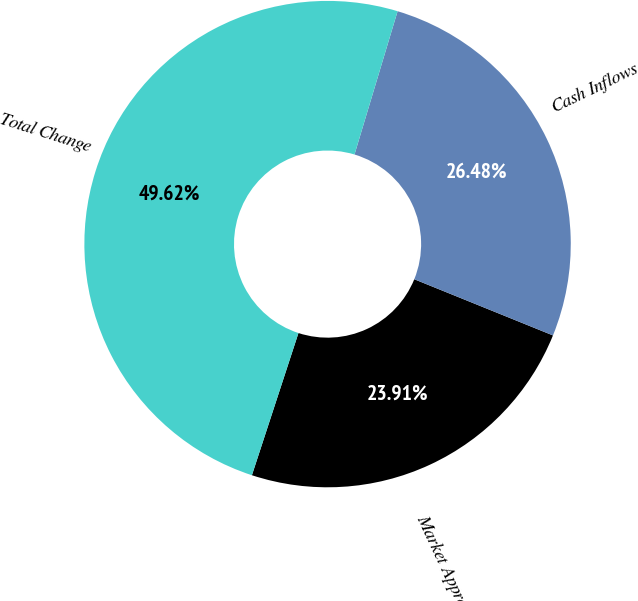Convert chart to OTSL. <chart><loc_0><loc_0><loc_500><loc_500><pie_chart><fcel>Market Appreciation/<fcel>Cash Inflows<fcel>Total Change<nl><fcel>23.91%<fcel>26.48%<fcel>49.62%<nl></chart> 